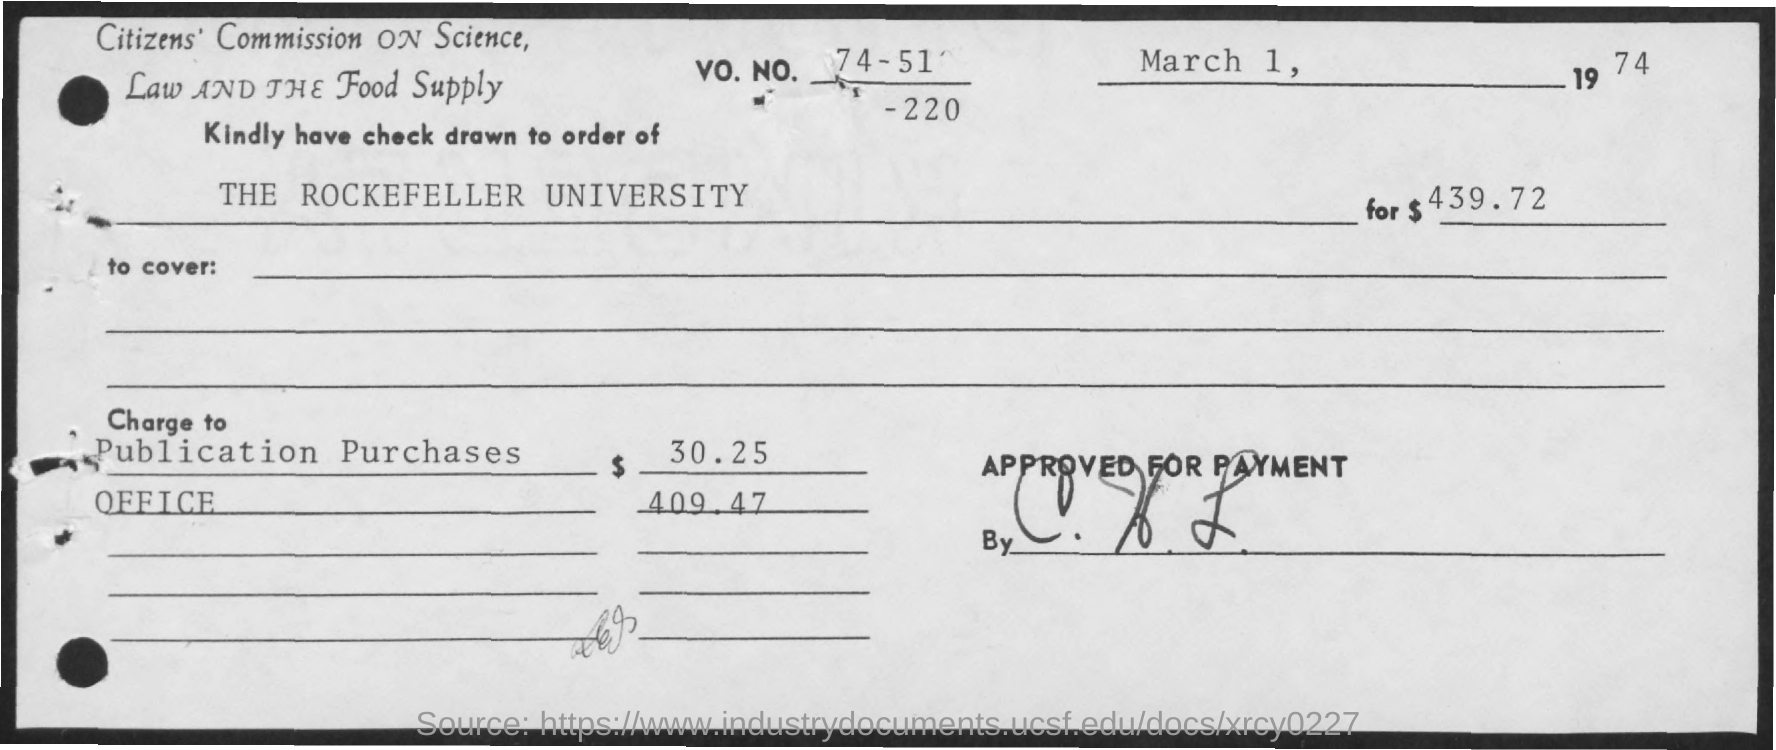What is the issued date of the check?
Provide a succinct answer. March 1, 1974. What is the Vo. No. mentioned in the check?
Provide a succinct answer. 74-51-220. What is the amount of check issued?
Keep it short and to the point. $439 72. 